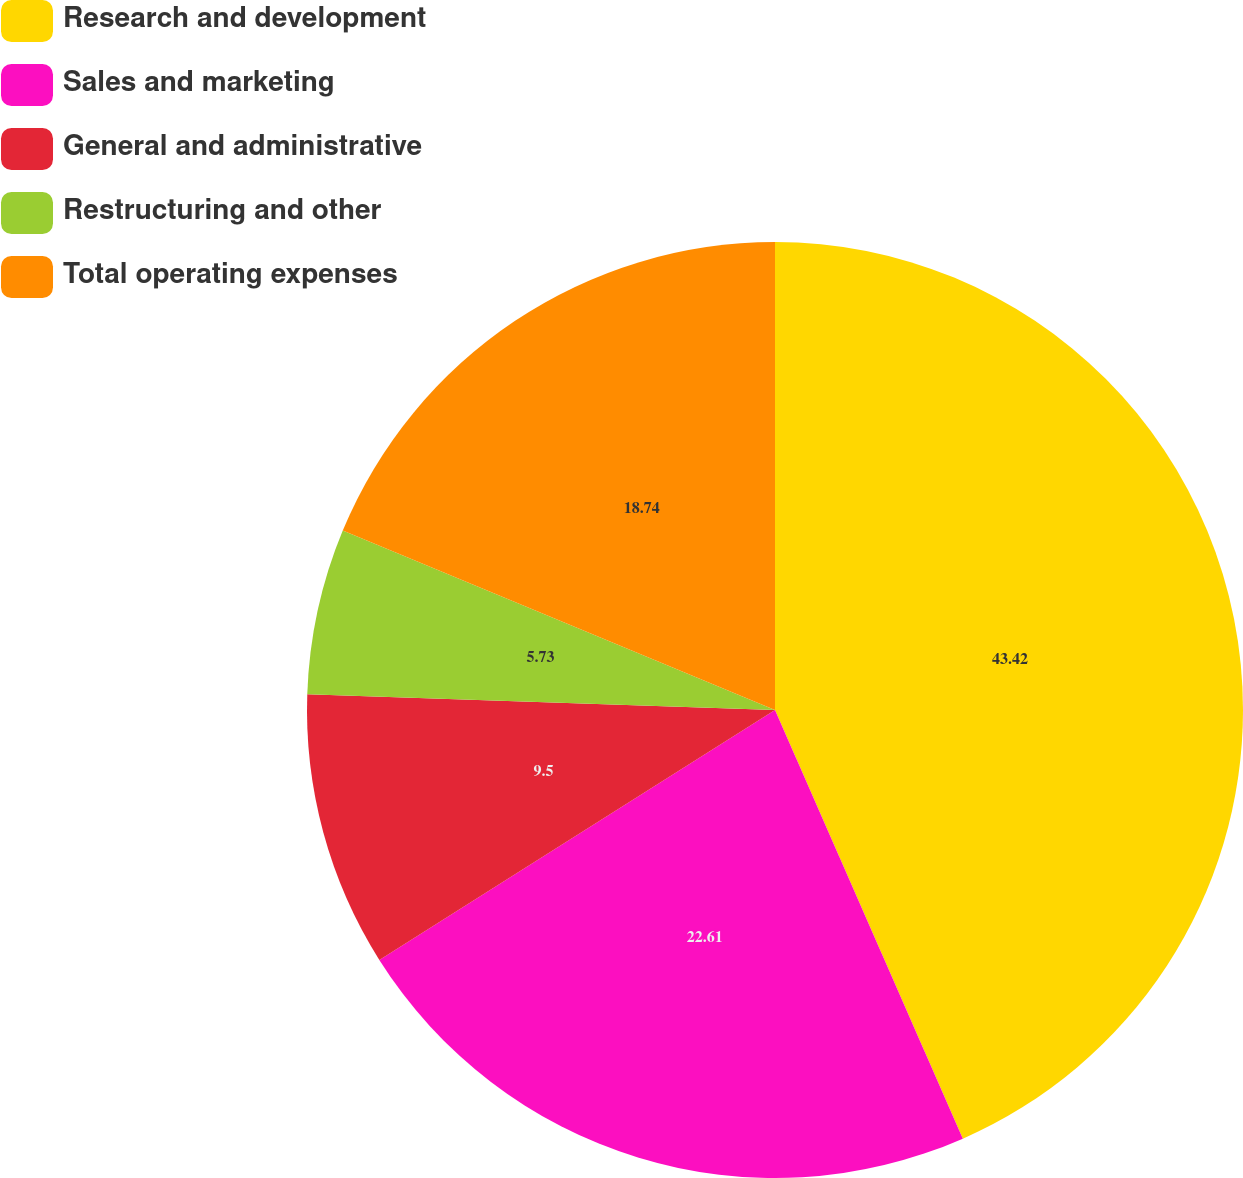<chart> <loc_0><loc_0><loc_500><loc_500><pie_chart><fcel>Research and development<fcel>Sales and marketing<fcel>General and administrative<fcel>Restructuring and other<fcel>Total operating expenses<nl><fcel>43.43%<fcel>22.61%<fcel>9.5%<fcel>5.73%<fcel>18.74%<nl></chart> 